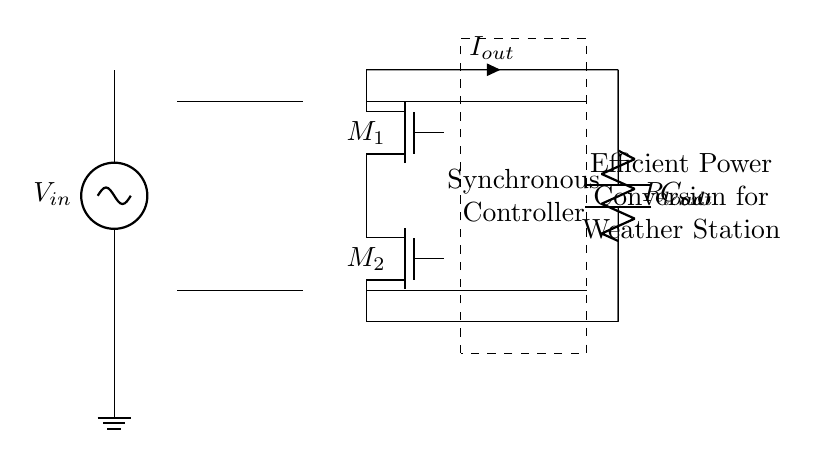What is the input voltage of this circuit? The input voltage is labeled as V_in on the left side of the circuit, indicating the source that feeds the synchronous rectifier.
Answer: V_in How many MOSFETs are present in the circuit? There are two MOSFETs labeled M_1 and M_2, both shown on the right side of the transformer, indicating their role in the rectification process.
Answer: 2 What component is used for filtering in this circuit? The component for filtering is labeled C_out, which is a capacitor and is connected to the output. This helps in smoothing the output voltage.
Answer: C_out What is the function of the synchronous controller? The synchronous controller, outlined by a dashed rectangle in the circuit, regulates the switching of the MOSFETs to optimize efficiency and manage power conversion.
Answer: Optimize efficiency What type of circuit is represented? The circuit is a synchronous rectifier, which is specifically designed for efficient power conversion in low-voltage applications like portable weather stations.
Answer: Synchronous rectifier What does the load resistor represent in this circuit? The load resistor, labeled R_load at the output, represents the resistance connected to the output that consumes the power delivered by the rectifier.
Answer: R_load 